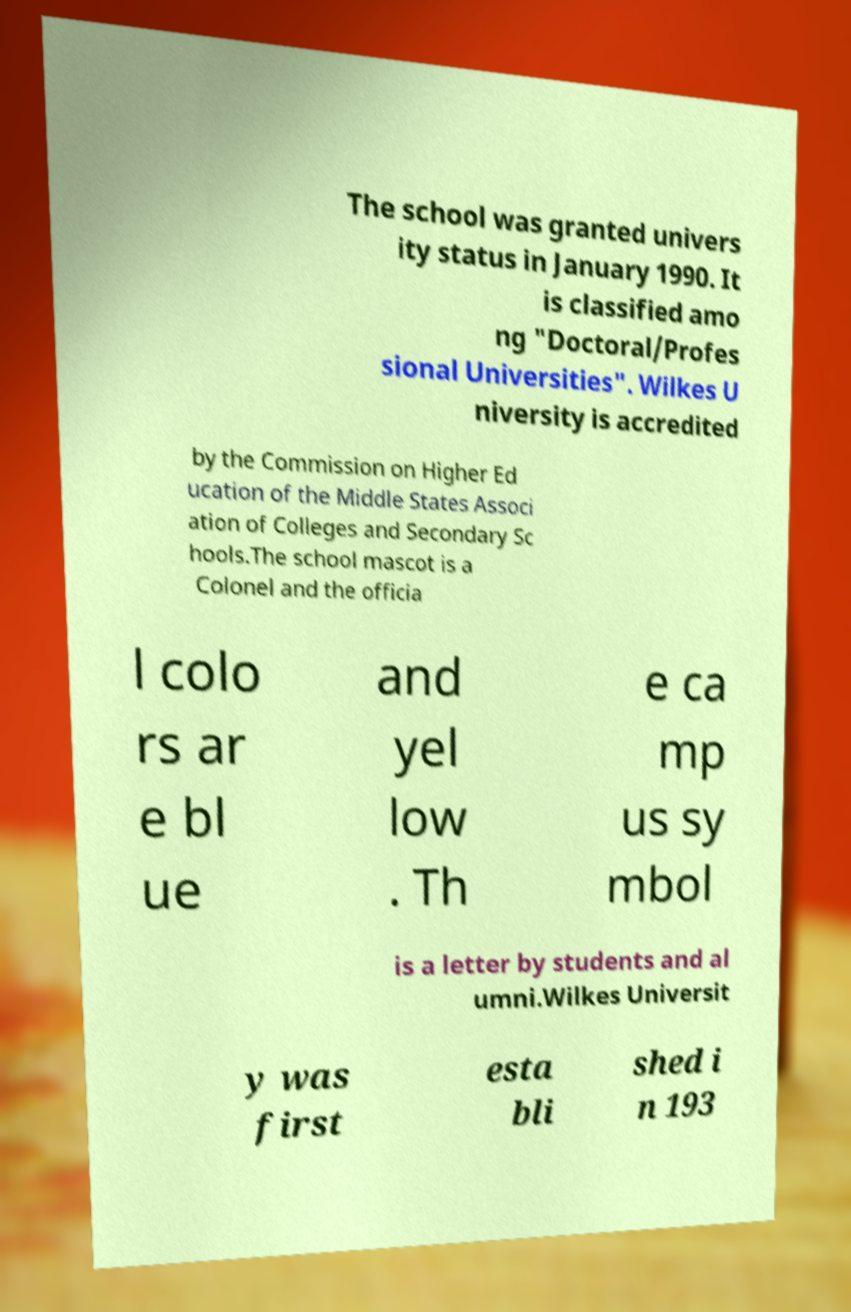Could you extract and type out the text from this image? The school was granted univers ity status in January 1990. It is classified amo ng "Doctoral/Profes sional Universities". Wilkes U niversity is accredited by the Commission on Higher Ed ucation of the Middle States Associ ation of Colleges and Secondary Sc hools.The school mascot is a Colonel and the officia l colo rs ar e bl ue and yel low . Th e ca mp us sy mbol is a letter by students and al umni.Wilkes Universit y was first esta bli shed i n 193 